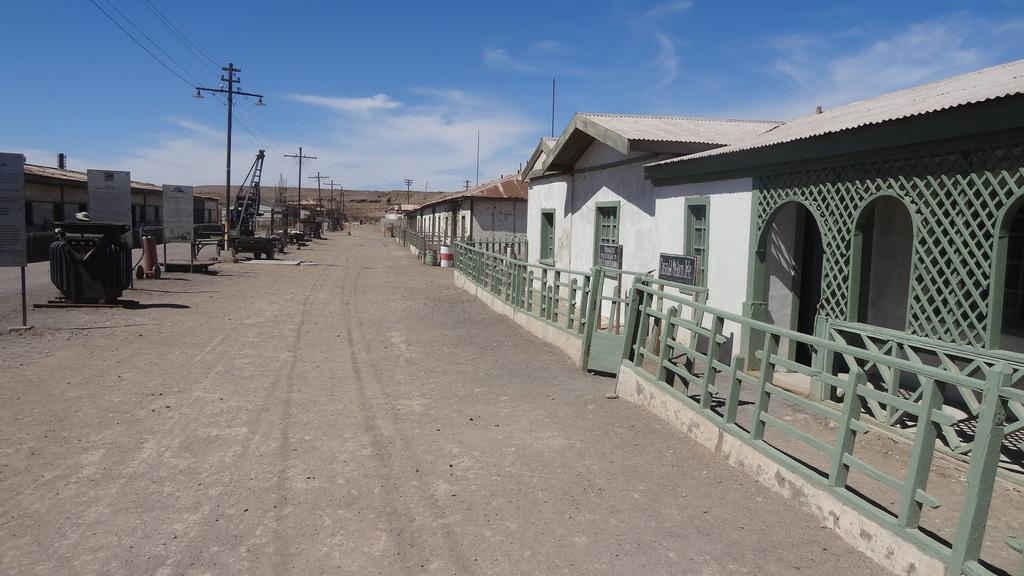What type of structures can be seen in the image? There are buildings in the image. What type of barrier is present in the image? There is fencing in the image. What type of transportation is visible in the image? Vehicles are visible in the image. What type of vertical structures are present in the image? Poles are present in the image. What type of wires are present in the image? Wires are present in the image. What type of flat, rectangular objects are present in the image? Boards are present in the image. What is the color of the sky in the image? The sky is blue and white in color. How many geese are flying over the buildings in the image? There are no geese present in the image. What type of fabric is draped over the fencing in the image? There is no fabric draped over the fencing in the image. 